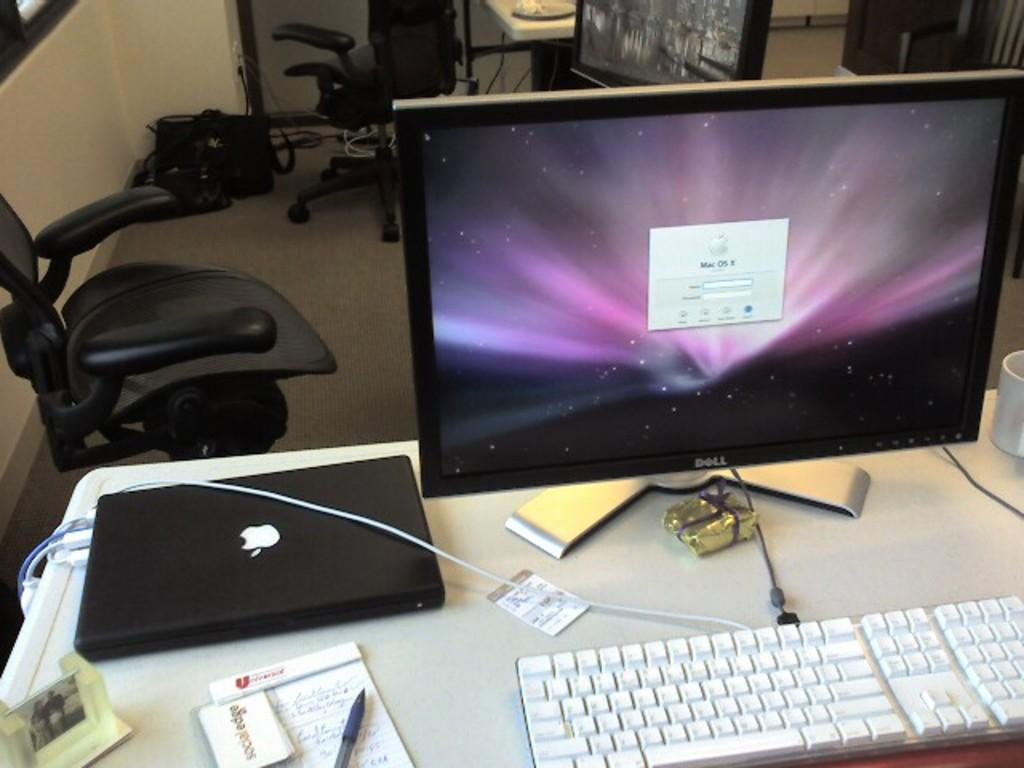<image>
Create a compact narrative representing the image presented. a computer screen that says mac os on it 